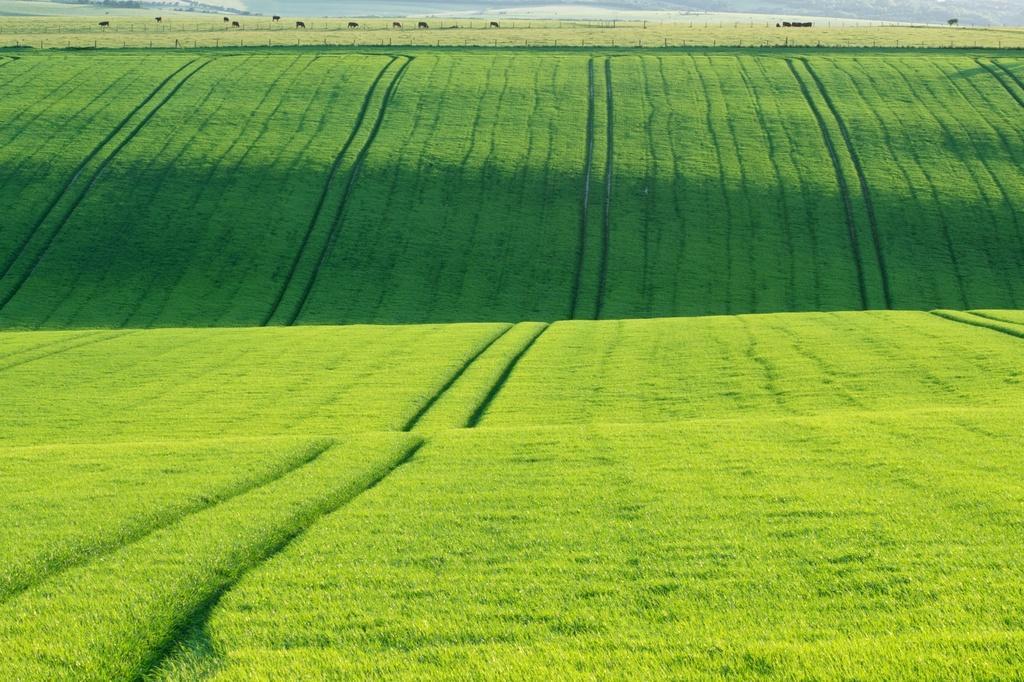In one or two sentences, can you explain what this image depicts? In the image I can see the grass. In the background I can see animals, fence and other objects. 